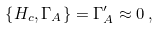Convert formula to latex. <formula><loc_0><loc_0><loc_500><loc_500>\left \{ H _ { c } , \Gamma _ { A } \right \} = \Gamma ^ { \prime } _ { A } \approx 0 \, ,</formula> 